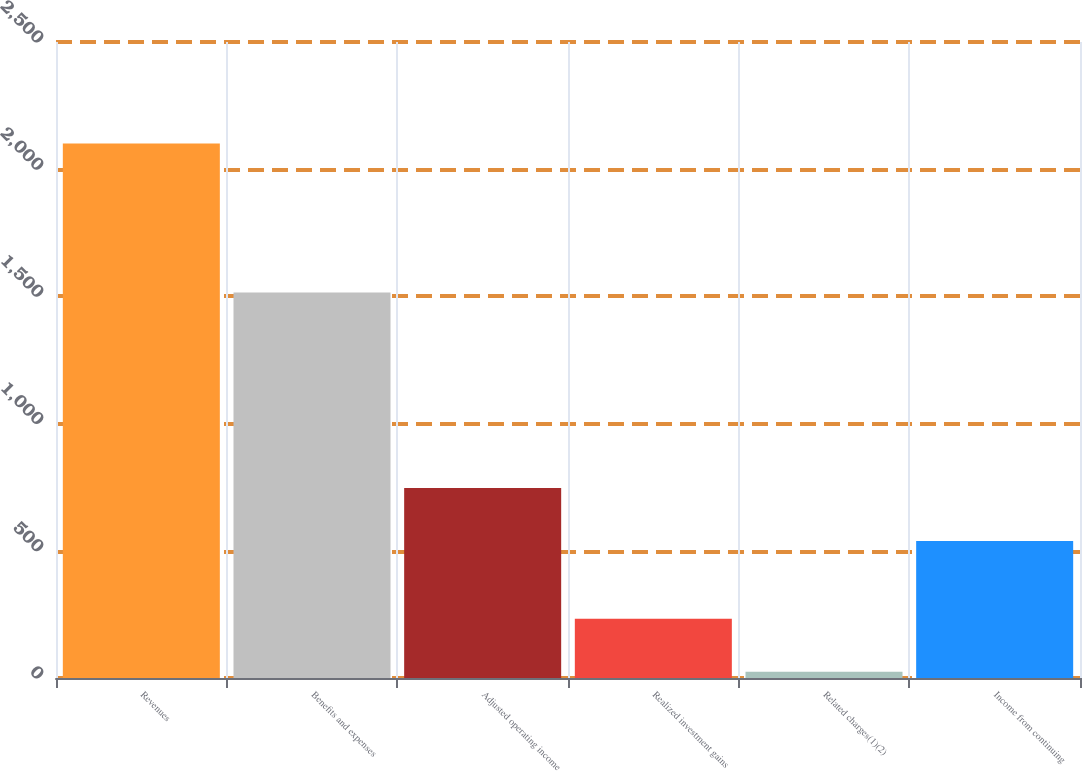Convert chart. <chart><loc_0><loc_0><loc_500><loc_500><bar_chart><fcel>Revenues<fcel>Benefits and expenses<fcel>Adjusted operating income<fcel>Realized investment gains<fcel>Related charges(1)(2)<fcel>Income from continuing<nl><fcel>2101<fcel>1515<fcel>746.6<fcel>232.6<fcel>25<fcel>539<nl></chart> 